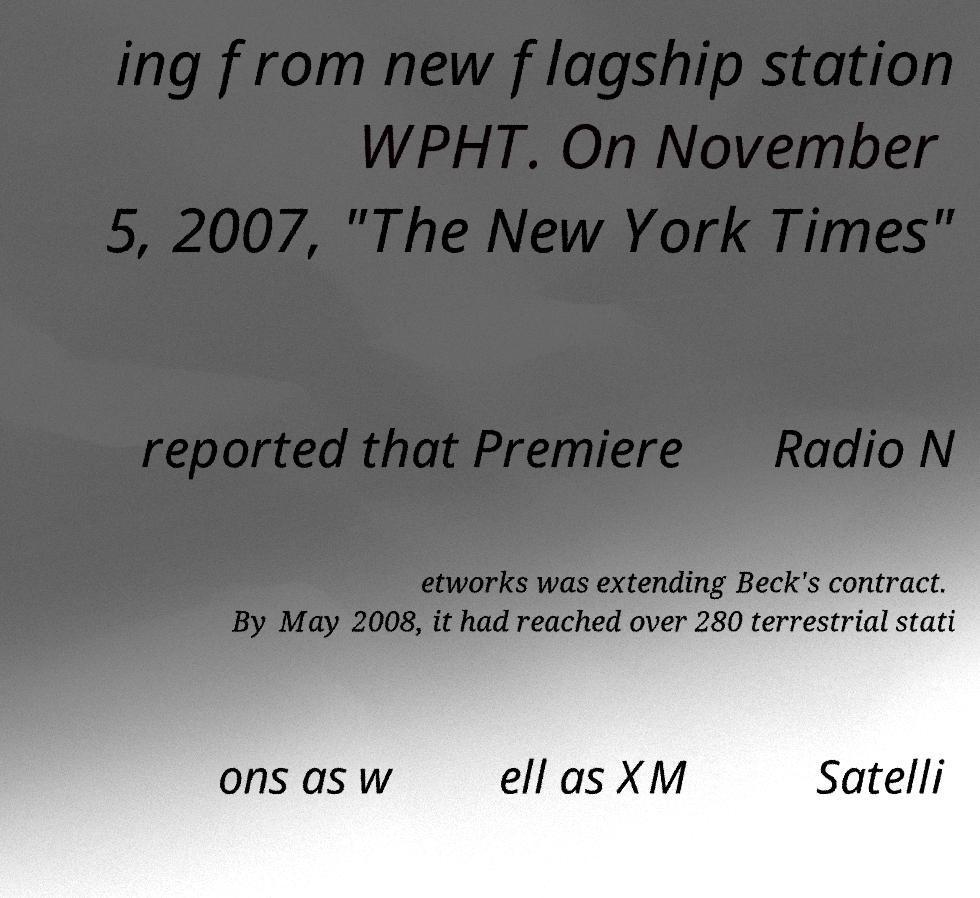What messages or text are displayed in this image? I need them in a readable, typed format. ing from new flagship station WPHT. On November 5, 2007, "The New York Times" reported that Premiere Radio N etworks was extending Beck's contract. By May 2008, it had reached over 280 terrestrial stati ons as w ell as XM Satelli 